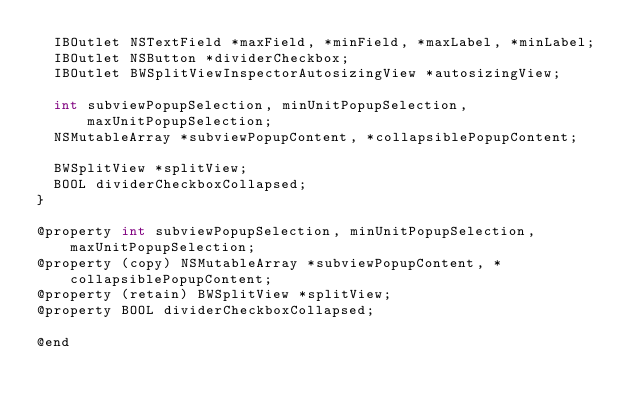<code> <loc_0><loc_0><loc_500><loc_500><_C_>	IBOutlet NSTextField *maxField, *minField, *maxLabel, *minLabel;
	IBOutlet NSButton *dividerCheckbox;
	IBOutlet BWSplitViewInspectorAutosizingView *autosizingView;
	
	int subviewPopupSelection, minUnitPopupSelection, maxUnitPopupSelection;
	NSMutableArray *subviewPopupContent, *collapsiblePopupContent;
	
	BWSplitView *splitView;
	BOOL dividerCheckboxCollapsed;
}

@property int subviewPopupSelection, minUnitPopupSelection, maxUnitPopupSelection;
@property (copy) NSMutableArray *subviewPopupContent, *collapsiblePopupContent;
@property (retain) BWSplitView *splitView;
@property BOOL dividerCheckboxCollapsed;

@end
</code> 